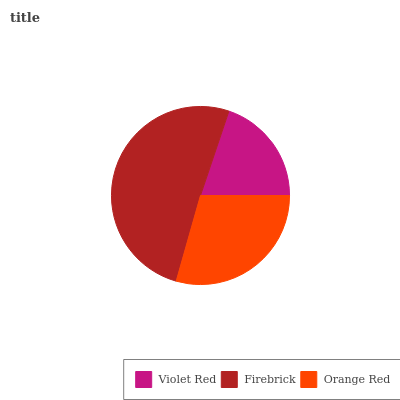Is Violet Red the minimum?
Answer yes or no. Yes. Is Firebrick the maximum?
Answer yes or no. Yes. Is Orange Red the minimum?
Answer yes or no. No. Is Orange Red the maximum?
Answer yes or no. No. Is Firebrick greater than Orange Red?
Answer yes or no. Yes. Is Orange Red less than Firebrick?
Answer yes or no. Yes. Is Orange Red greater than Firebrick?
Answer yes or no. No. Is Firebrick less than Orange Red?
Answer yes or no. No. Is Orange Red the high median?
Answer yes or no. Yes. Is Orange Red the low median?
Answer yes or no. Yes. Is Violet Red the high median?
Answer yes or no. No. Is Firebrick the low median?
Answer yes or no. No. 